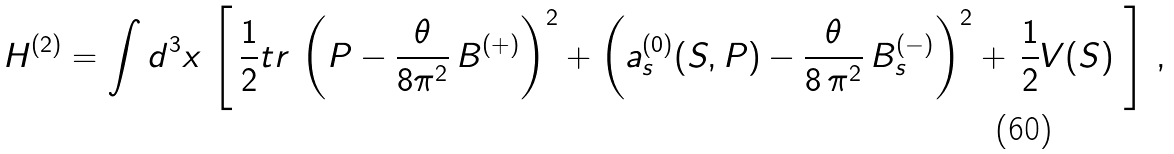<formula> <loc_0><loc_0><loc_500><loc_500>H ^ { ( 2 ) } = \int d ^ { 3 } { x } \, \left [ \, \frac { 1 } { 2 } t r \, \left ( P - \frac { \theta } { 8 \pi ^ { 2 } } \, B ^ { ( + ) } \right ) ^ { 2 } + \left ( a _ { s } ^ { ( 0 ) } ( S , P ) - \frac { \theta } { 8 \, \pi ^ { 2 } } \, B _ { s } ^ { ( - ) } \right ) ^ { 2 } + \, \frac { 1 } { 2 } V ( S ) \ \right ] \, ,</formula> 